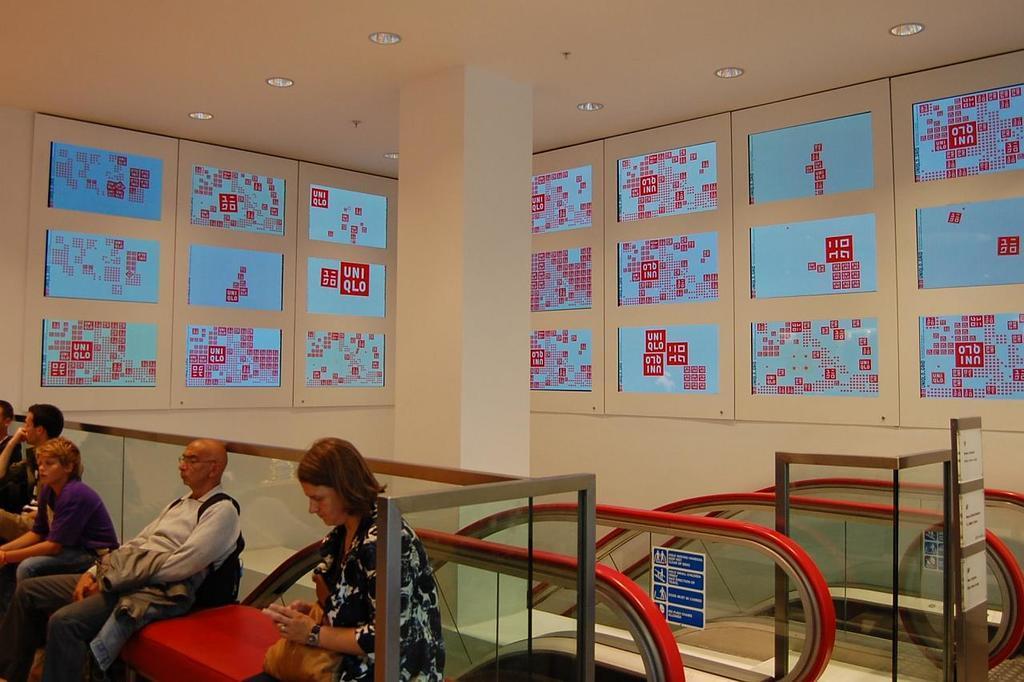Please provide a concise description of this image. In the picture there are many people sitting on the bench, there are escalators present, on the wall there are many banners present with the text, there are lights. 